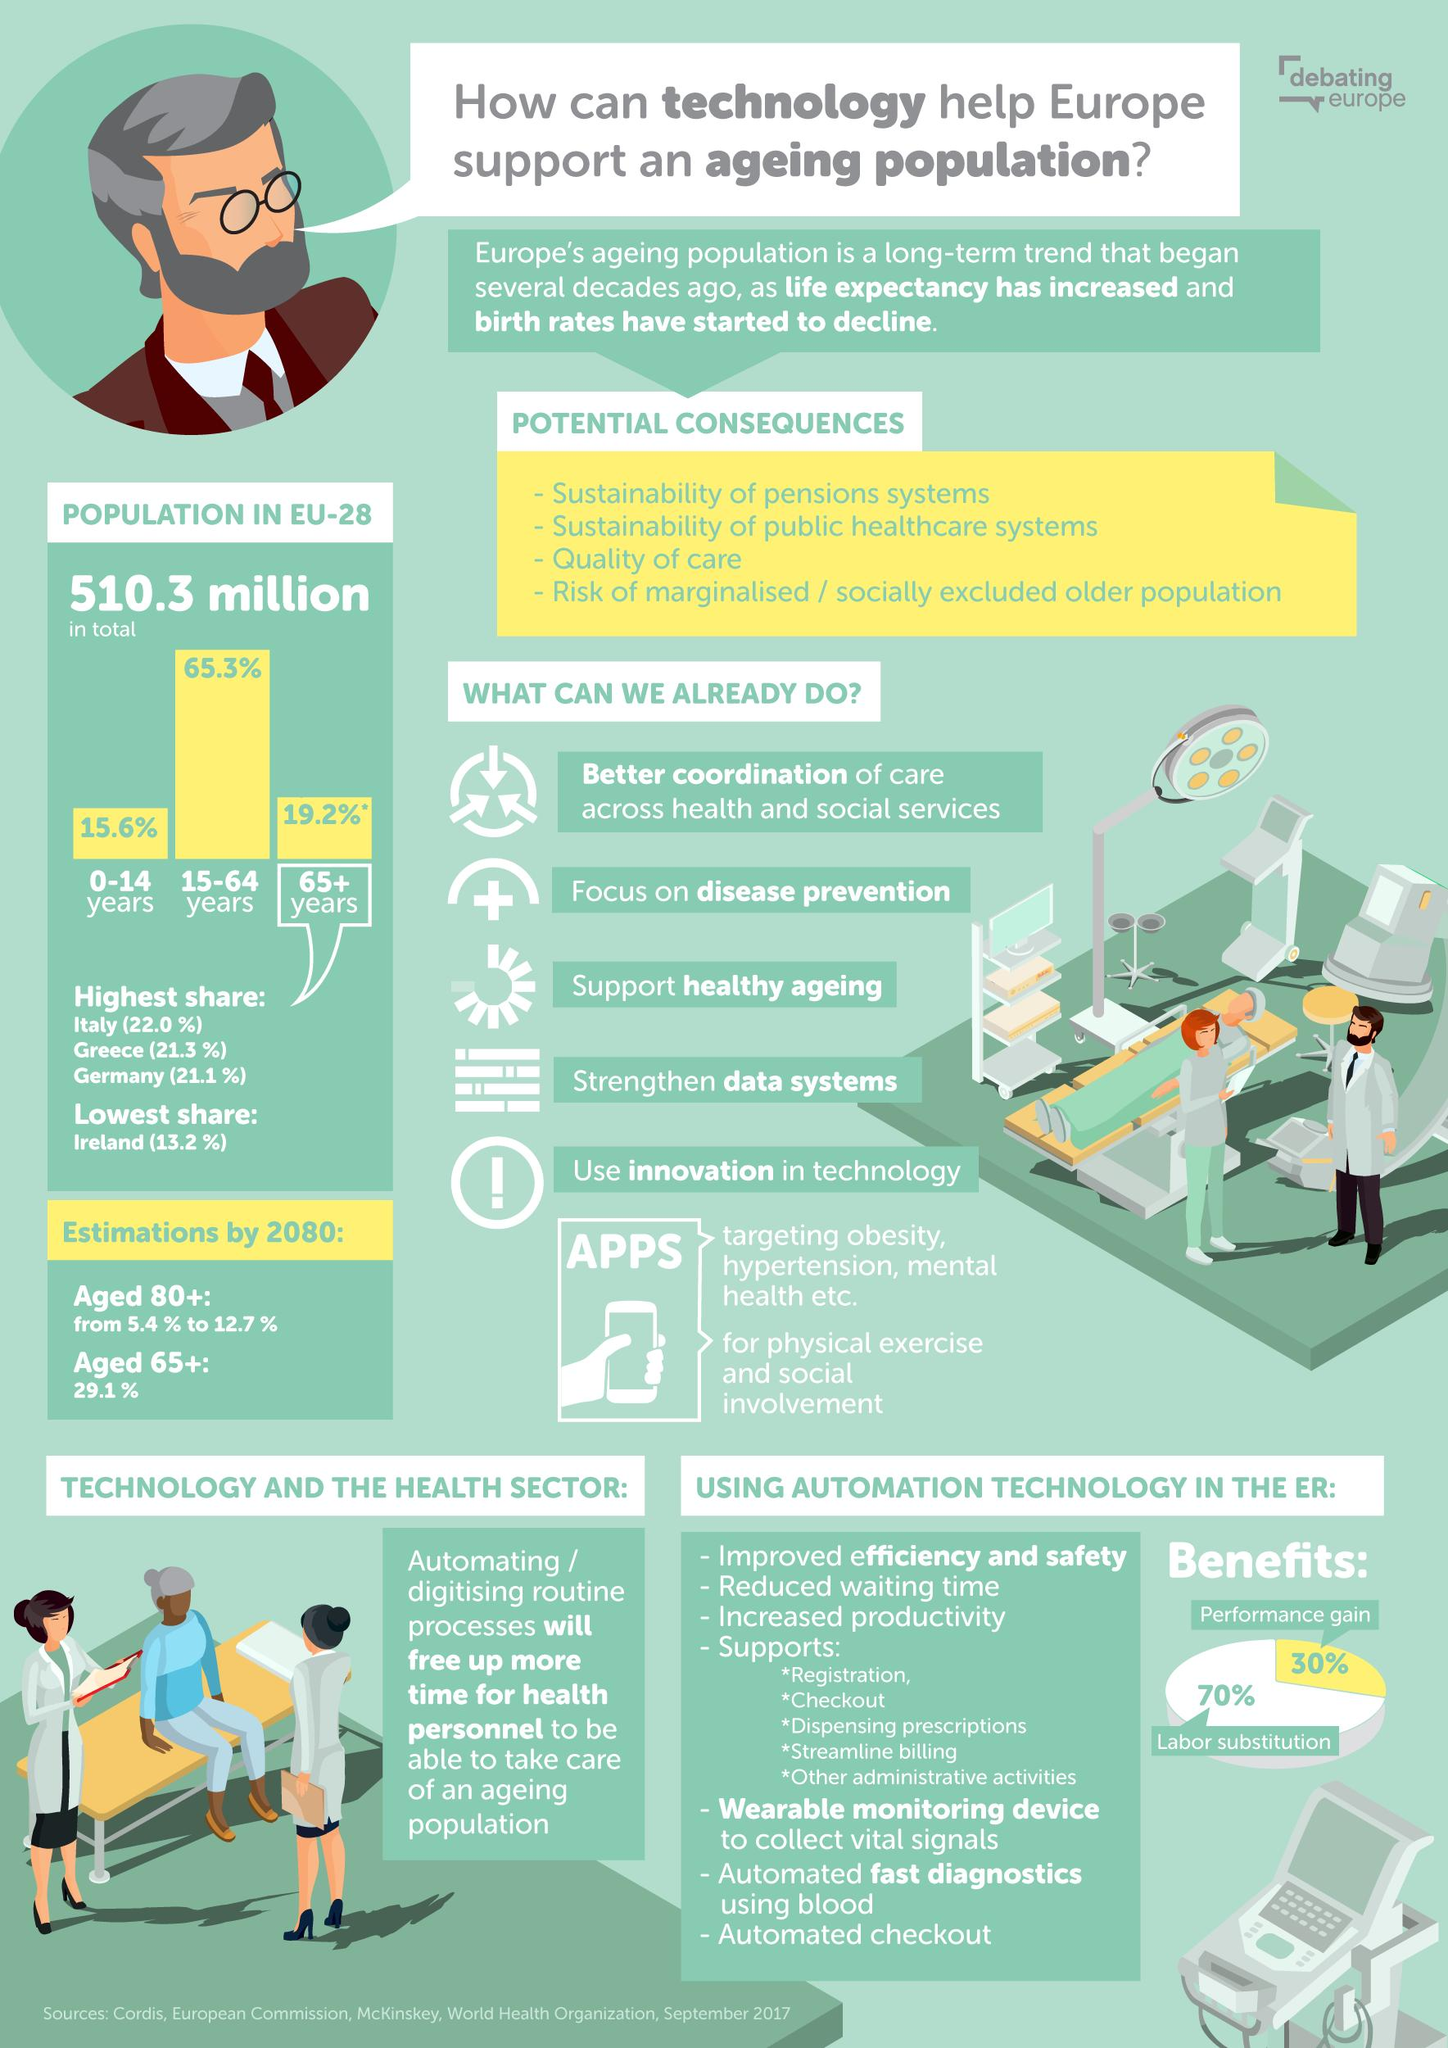List a handful of essential elements in this visual. Labor substitution has the highest share-performance gain compared to the other two options. Under the heading "Potential Consequences," there are 4 points. 